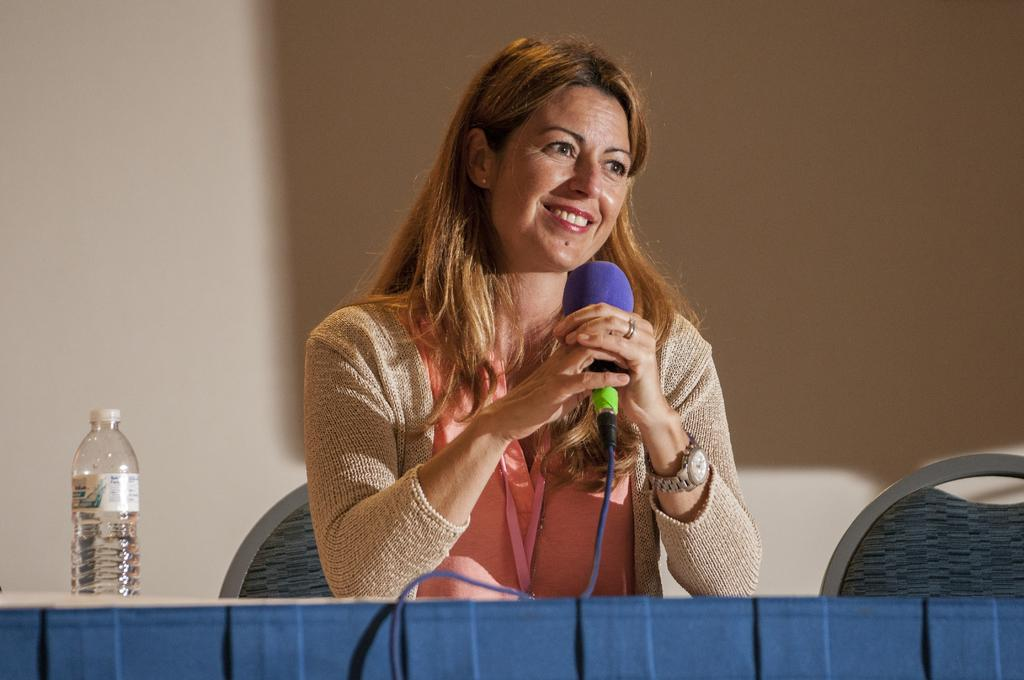Who is the main subject in the image? There is a woman in the image. What is the woman wearing? The woman is wearing a pink dress. What is the woman doing in the image? The woman is sitting on a chair and holding a microphone in her hand. What is the woman in front of? The woman is in front of a table. What can be seen in the background of the image? There is a water bottle in the background of the image. What type of donkey can be seen in the image? There is no donkey present in the image. What is the woman's throat doing in the image? The woman's throat is not visible in the image, so it cannot be determined what it is doing. 